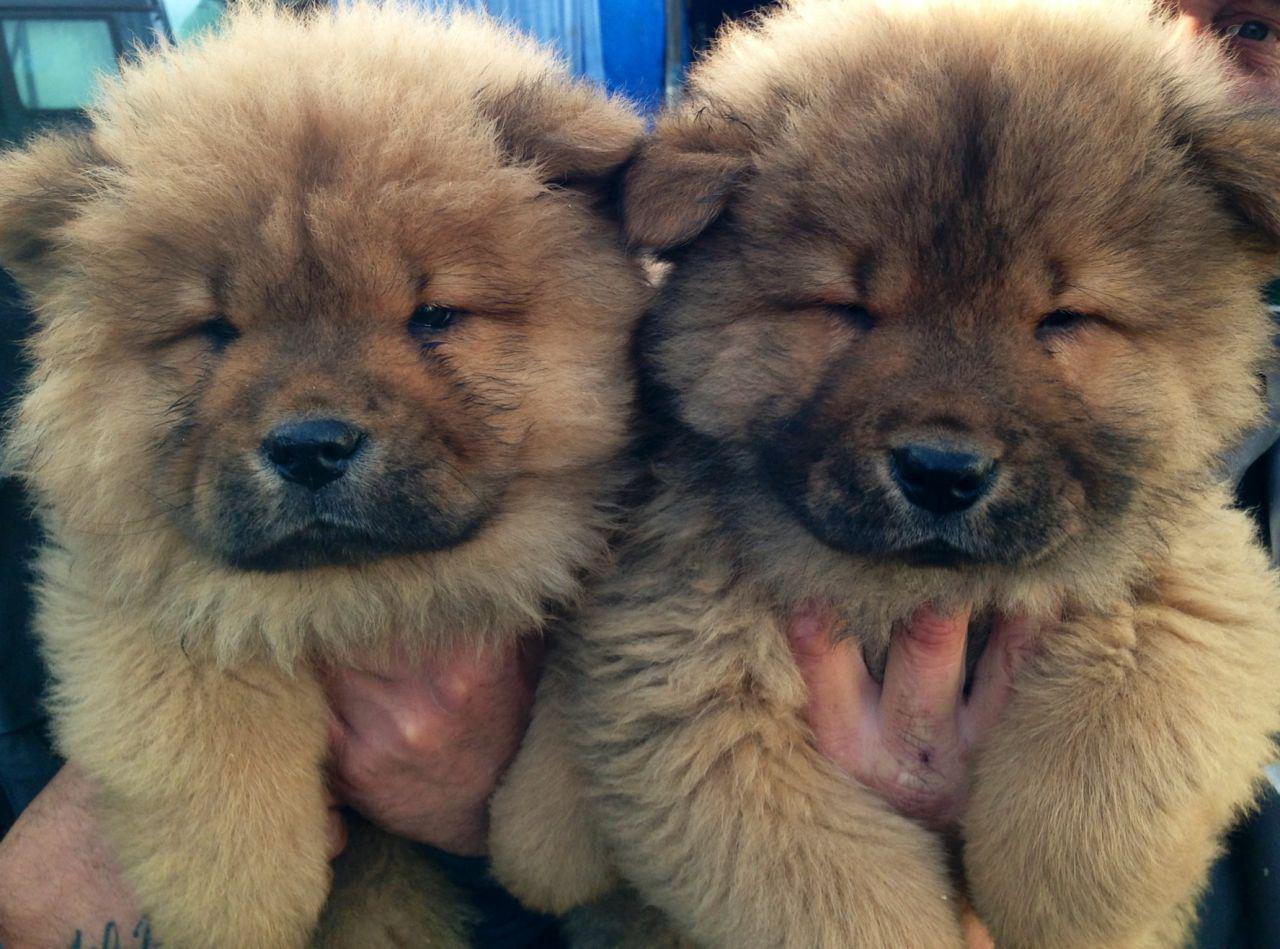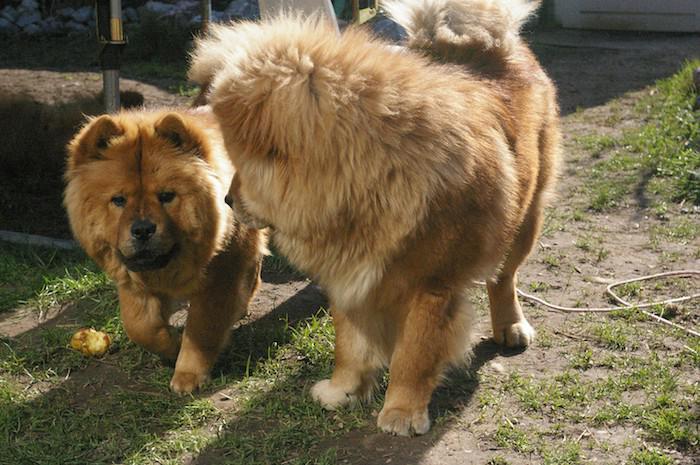The first image is the image on the left, the second image is the image on the right. For the images displayed, is the sentence "In at least one image there is a tan fluffy dog sitting in the grass" factually correct? Answer yes or no. No. The first image is the image on the left, the second image is the image on the right. Evaluate the accuracy of this statement regarding the images: "There are only two dogs total and none are laying down.". Is it true? Answer yes or no. No. 